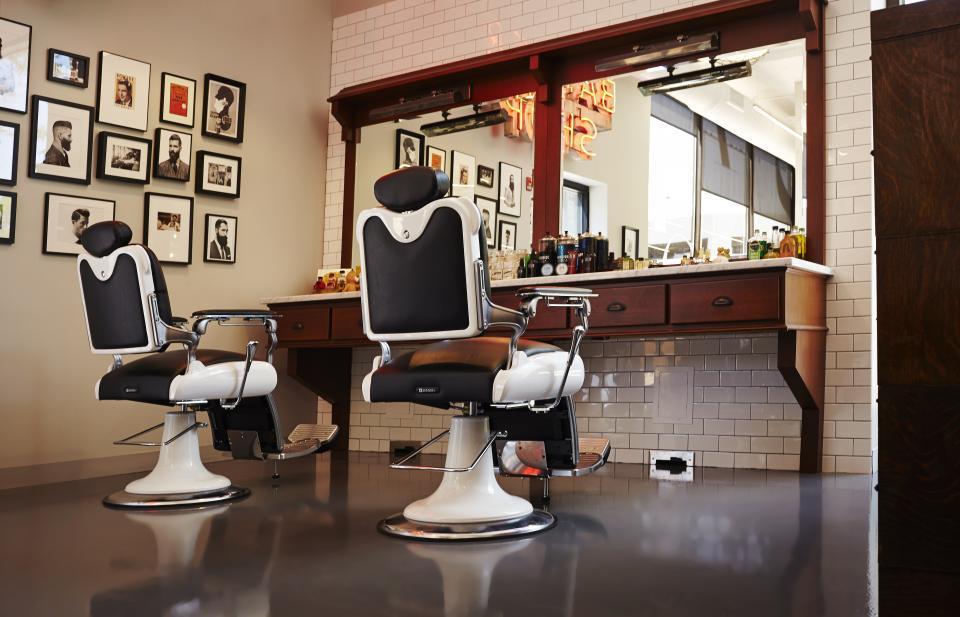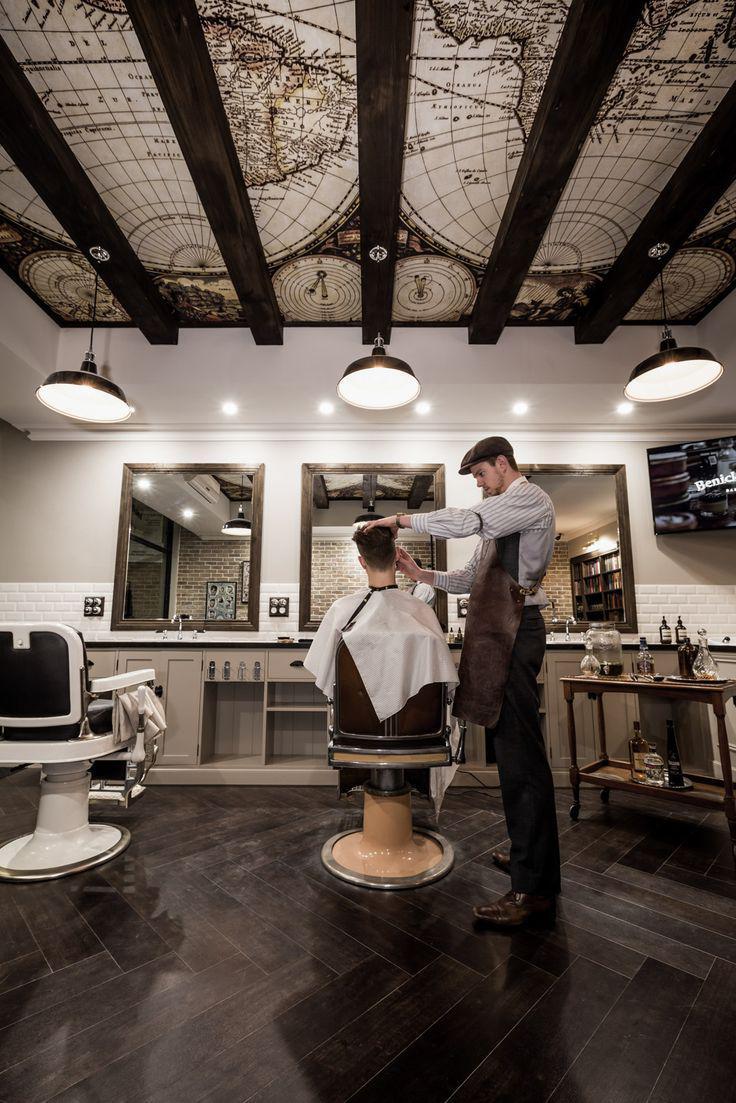The first image is the image on the left, the second image is the image on the right. For the images displayed, is the sentence "In one image, one barber has a customer in his chair and one does not." factually correct? Answer yes or no. No. The first image is the image on the left, the second image is the image on the right. Analyze the images presented: Is the assertion "THere are exactly two people in the image on the left." valid? Answer yes or no. No. 